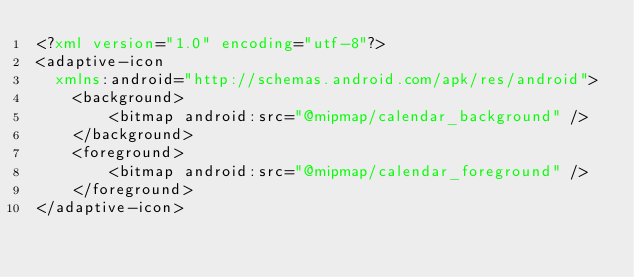<code> <loc_0><loc_0><loc_500><loc_500><_XML_><?xml version="1.0" encoding="utf-8"?>
<adaptive-icon
  xmlns:android="http://schemas.android.com/apk/res/android">
    <background>
        <bitmap android:src="@mipmap/calendar_background" />
    </background>
    <foreground>
        <bitmap android:src="@mipmap/calendar_foreground" />
    </foreground>
</adaptive-icon></code> 